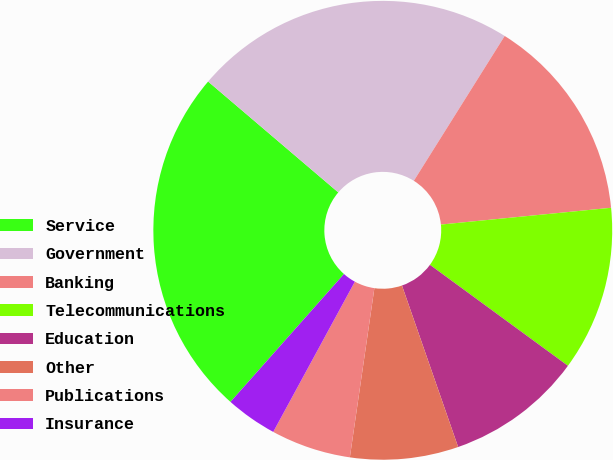<chart> <loc_0><loc_0><loc_500><loc_500><pie_chart><fcel>Service<fcel>Government<fcel>Banking<fcel>Telecommunications<fcel>Education<fcel>Other<fcel>Publications<fcel>Insurance<nl><fcel>24.68%<fcel>22.69%<fcel>14.52%<fcel>11.62%<fcel>9.62%<fcel>7.62%<fcel>5.63%<fcel>3.63%<nl></chart> 